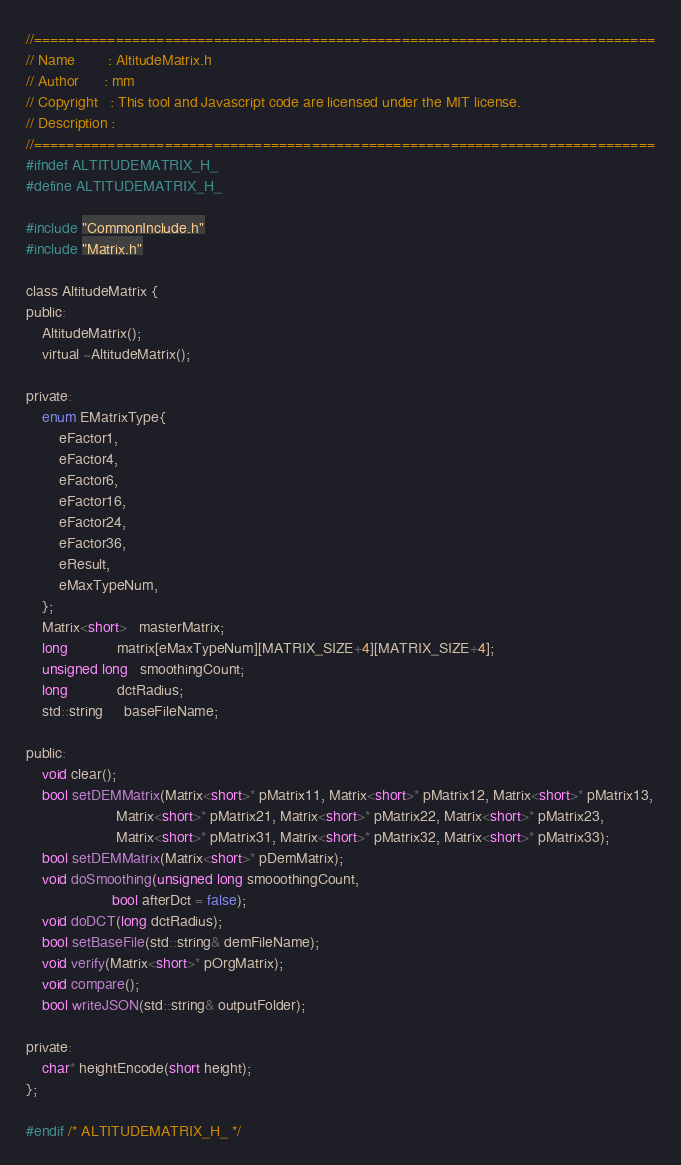Convert code to text. <code><loc_0><loc_0><loc_500><loc_500><_C_>//============================================================================
// Name        : AltitudeMatrix.h
// Author      : mm
// Copyright   : This tool and Javascript code are licensed under the MIT license.
// Description :
//============================================================================
#ifndef ALTITUDEMATRIX_H_
#define ALTITUDEMATRIX_H_

#include "CommonInclude.h"
#include "Matrix.h"

class AltitudeMatrix {
public:
	AltitudeMatrix();
	virtual ~AltitudeMatrix();

private:
	enum EMatrixType{
		eFactor1,
		eFactor4,
		eFactor6,
		eFactor16,
		eFactor24,
		eFactor36,
		eResult,
		eMaxTypeNum,
	};
	Matrix<short>   masterMatrix;
	long            matrix[eMaxTypeNum][MATRIX_SIZE+4][MATRIX_SIZE+4];
	unsigned long   smoothingCount;
    long            dctRadius;
	std::string     baseFileName;

public:
	void clear();
	bool setDEMMatrix(Matrix<short>* pMatrix11, Matrix<short>* pMatrix12, Matrix<short>* pMatrix13,
					  Matrix<short>* pMatrix21, Matrix<short>* pMatrix22, Matrix<short>* pMatrix23,
					  Matrix<short>* pMatrix31, Matrix<short>* pMatrix32, Matrix<short>* pMatrix33);
	bool setDEMMatrix(Matrix<short>* pDemMatrix);
	void doSmoothing(unsigned long smooothingCount,
                     bool afterDct = false);
    void doDCT(long dctRadius);
	bool setBaseFile(std::string& demFileName);
	void verify(Matrix<short>* pOrgMatrix);
    void compare();
	bool writeJSON(std::string& outputFolder);

private:
	char* heightEncode(short height);
};

#endif /* ALTITUDEMATRIX_H_ */
</code> 